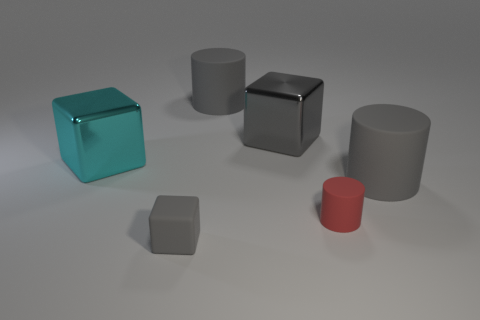Are there any rubber cylinders behind the large cyan shiny block?
Your answer should be very brief. Yes. There is a large gray thing that is the same shape as the big cyan object; what material is it?
Ensure brevity in your answer.  Metal. What number of other objects are there of the same shape as the tiny red object?
Provide a succinct answer. 2. There is a gray matte object that is in front of the red cylinder on the right side of the cyan thing; how many metal blocks are in front of it?
Make the answer very short. 0. What number of other objects are the same shape as the small red object?
Your response must be concise. 2. Does the big metal thing to the right of the cyan metal cube have the same color as the small cube?
Make the answer very short. Yes. What is the shape of the tiny rubber thing that is behind the small thing in front of the small red cylinder behind the gray rubber block?
Provide a short and direct response. Cylinder. There is a cyan shiny object; is its size the same as the gray cube that is behind the small gray matte block?
Offer a terse response. Yes. Is there a metallic block that has the same size as the rubber cube?
Offer a terse response. No. What number of other objects are there of the same material as the small cylinder?
Make the answer very short. 3. 